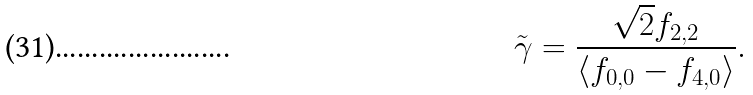Convert formula to latex. <formula><loc_0><loc_0><loc_500><loc_500>\tilde { \gamma } = \frac { \sqrt { 2 } f _ { 2 , 2 } } { \langle f _ { 0 , 0 } - f _ { 4 , 0 } \rangle } .</formula> 